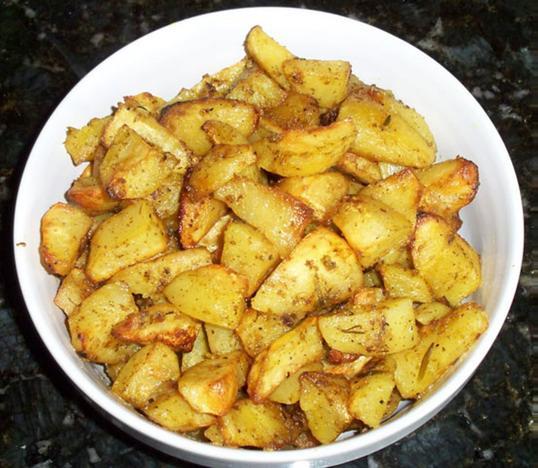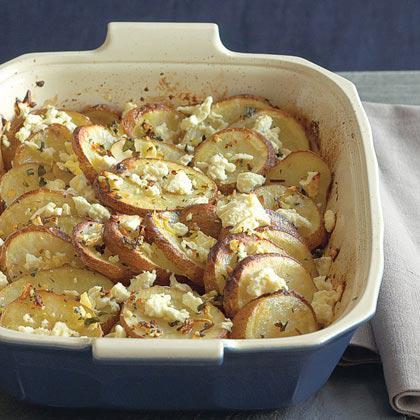The first image is the image on the left, the second image is the image on the right. Examine the images to the left and right. Is the description "Both food items are in bowls." accurate? Answer yes or no. Yes. The first image is the image on the left, the second image is the image on the right. Considering the images on both sides, is "The left image shows a round bowl without handles containing potato sections, and the right image shows a white interiored dish with handles containing sliced potato pieces." valid? Answer yes or no. Yes. 